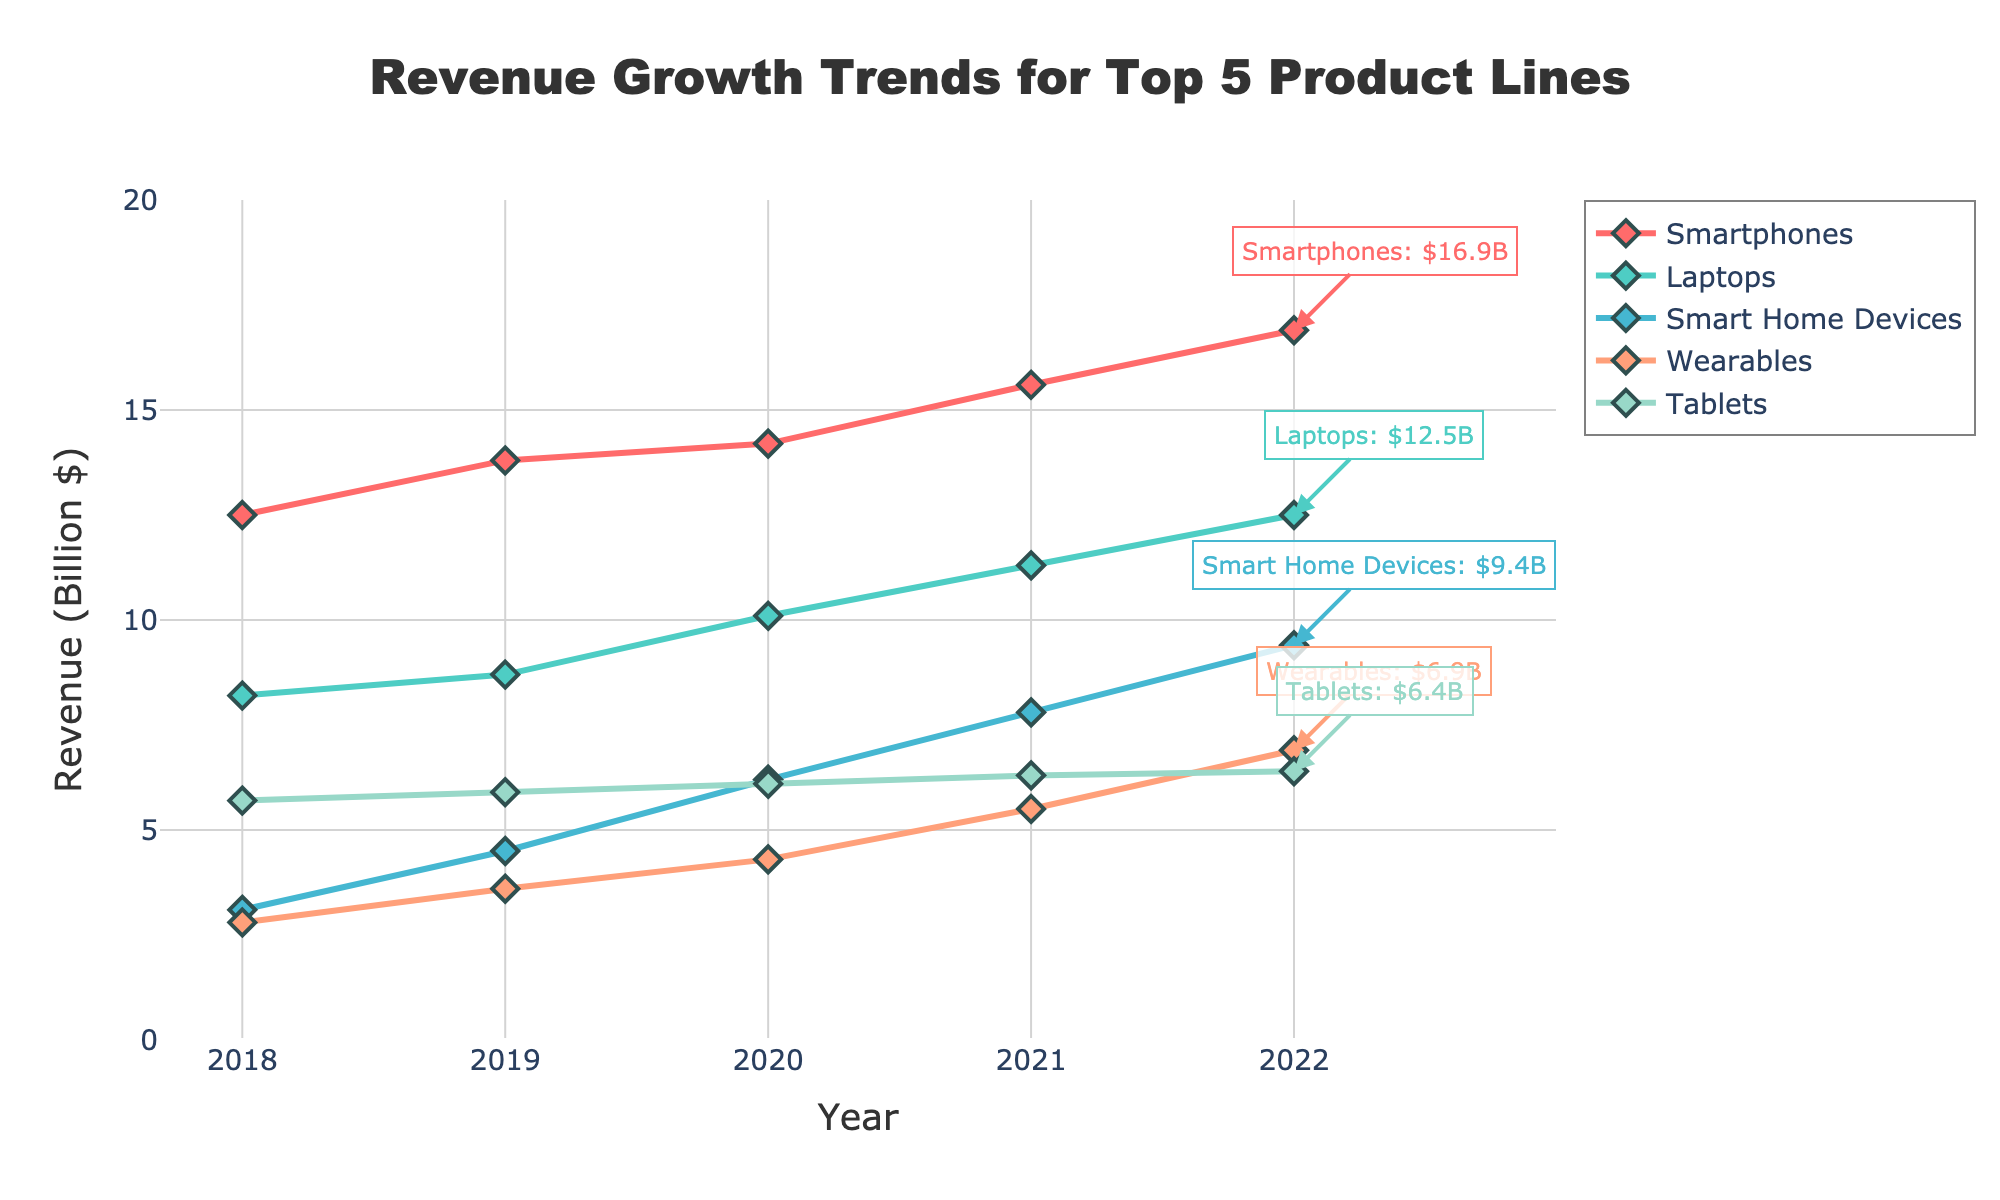What product line had the highest revenue in 2022? The line chart shows different product lines over 5 years. In 2022, the line for Smartphones is the highest on the vertical axis.
Answer: Smartphones Which product line showed the most consistent growth over the 5 years? By observing the slopes and smoothness of the lines, the Smartphones line has a consistent upward trend every year.
Answer: Smartphones How much did the revenue for Smart Home Devices increase from 2018 to 2022? The revenue for Smart Home Devices in 2018 was 3.1 billion dollars and in 2022 it was 9.4 billion dollars. The increase is 9.4 - 3.1 = 6.3.
Answer: 6.3 billion dollars Between which two consecutive years did Wearables see the largest revenue increase? Comparing the differences year by year: 2018-2019 (3.6 - 2.8 = 0.8), 2019-2020 (4.3 - 3.6 = 0.7), 2020-2021 (5.5 - 4.3 = 1.2), 2021-2022 (6.9 - 5.5 = 1.4). The largest increase is between 2021 and 2022.
Answer: 2021 and 2022 What is the combined revenue of Laptops and Tablets in 2020? The revenue for Laptops in 2020 is 10.1 billion dollars and for Tablets is 6.1 billion dollars. The combined revenue is 10.1 + 6.1 = 16.2.
Answer: 16.2 billion dollars Which product line had the smallest revenue in 2018, and what was it? In 2018, the line for Wearables is the lowest, corresponding to a revenue of 2.8 billion dollars.
Answer: Wearables, 2.8 billion dollars Did any product line's revenue decline over any year? By checking the trend for each product line, none of the lines shows a downward slope; all product lines show an upward or steady trend every year.
Answer: No How much more revenue did Smart Home Devices generate compared to Tablets in 2022? The revenue for Smart Home Devices in 2022 is 9.4 billion dollars and for Tablets is 6.4 billion dollars. The difference is 9.4 - 6.4 = 3.0.
Answer: 3.0 billion dollars Which product lines had a greater revenue than Wearables in 2021? Revenue for Wearables in 2021 is 5.5 billion dollars. Smartphones (15.6), Laptops (11.3), Smart Home Devices (7.8) all had higher revenues than Wearables in that year.
Answer: Smartphones, Laptops, Smart Home Devices What was the average annual growth rate for Tablets from 2018 to 2022? The revenue for Tablets in 2018 was 5.7 billion dollars and in 2022 it was 6.4 billion dollars. The growth over 4 years is 6.4 - 5.7 = 0.7. The average annual growth rate is 0.7 / 4 = 0.175 billion dollars per year.
Answer: 0.175 billion dollars per year 